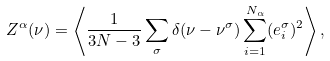<formula> <loc_0><loc_0><loc_500><loc_500>Z ^ { \alpha } ( \nu ) = \left < \frac { 1 } { 3 N - 3 } \sum _ { \sigma } \delta ( \nu - \nu ^ { \sigma } ) \sum _ { i = 1 } ^ { N _ { \alpha } } ( e _ { i } ^ { \sigma } ) ^ { 2 } \right > ,</formula> 